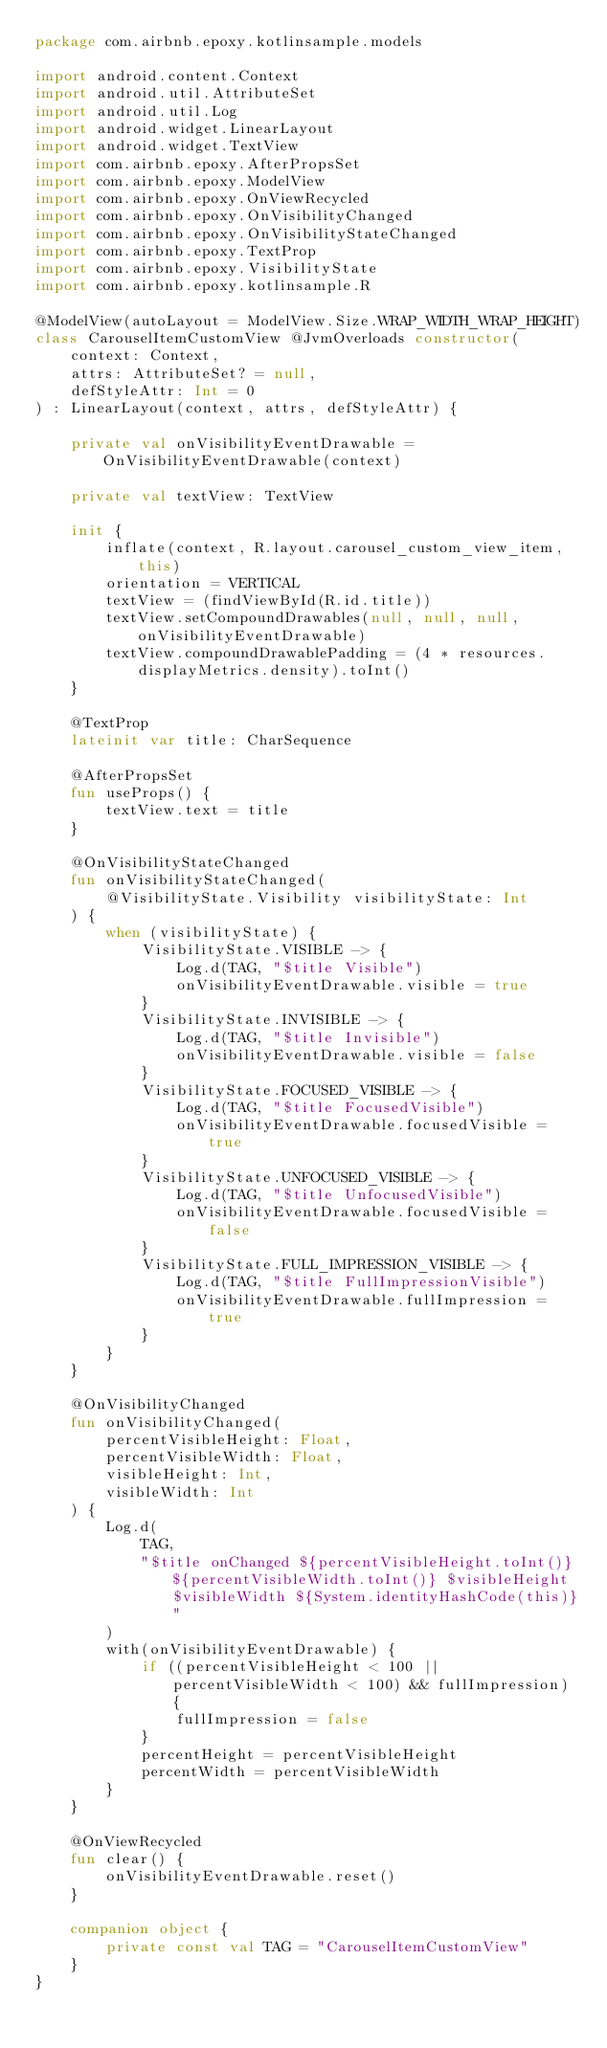<code> <loc_0><loc_0><loc_500><loc_500><_Kotlin_>package com.airbnb.epoxy.kotlinsample.models

import android.content.Context
import android.util.AttributeSet
import android.util.Log
import android.widget.LinearLayout
import android.widget.TextView
import com.airbnb.epoxy.AfterPropsSet
import com.airbnb.epoxy.ModelView
import com.airbnb.epoxy.OnViewRecycled
import com.airbnb.epoxy.OnVisibilityChanged
import com.airbnb.epoxy.OnVisibilityStateChanged
import com.airbnb.epoxy.TextProp
import com.airbnb.epoxy.VisibilityState
import com.airbnb.epoxy.kotlinsample.R

@ModelView(autoLayout = ModelView.Size.WRAP_WIDTH_WRAP_HEIGHT)
class CarouselItemCustomView @JvmOverloads constructor(
    context: Context,
    attrs: AttributeSet? = null,
    defStyleAttr: Int = 0
) : LinearLayout(context, attrs, defStyleAttr) {

    private val onVisibilityEventDrawable = OnVisibilityEventDrawable(context)

    private val textView: TextView

    init {
        inflate(context, R.layout.carousel_custom_view_item, this)
        orientation = VERTICAL
        textView = (findViewById(R.id.title))
        textView.setCompoundDrawables(null, null, null, onVisibilityEventDrawable)
        textView.compoundDrawablePadding = (4 * resources.displayMetrics.density).toInt()
    }

    @TextProp
    lateinit var title: CharSequence

    @AfterPropsSet
    fun useProps() {
        textView.text = title
    }

    @OnVisibilityStateChanged
    fun onVisibilityStateChanged(
        @VisibilityState.Visibility visibilityState: Int
    ) {
        when (visibilityState) {
            VisibilityState.VISIBLE -> {
                Log.d(TAG, "$title Visible")
                onVisibilityEventDrawable.visible = true
            }
            VisibilityState.INVISIBLE -> {
                Log.d(TAG, "$title Invisible")
                onVisibilityEventDrawable.visible = false
            }
            VisibilityState.FOCUSED_VISIBLE -> {
                Log.d(TAG, "$title FocusedVisible")
                onVisibilityEventDrawable.focusedVisible = true
            }
            VisibilityState.UNFOCUSED_VISIBLE -> {
                Log.d(TAG, "$title UnfocusedVisible")
                onVisibilityEventDrawable.focusedVisible = false
            }
            VisibilityState.FULL_IMPRESSION_VISIBLE -> {
                Log.d(TAG, "$title FullImpressionVisible")
                onVisibilityEventDrawable.fullImpression = true
            }
        }
    }

    @OnVisibilityChanged
    fun onVisibilityChanged(
        percentVisibleHeight: Float,
        percentVisibleWidth: Float,
        visibleHeight: Int,
        visibleWidth: Int
    ) {
        Log.d(
            TAG,
            "$title onChanged ${percentVisibleHeight.toInt()} ${percentVisibleWidth.toInt()} $visibleHeight $visibleWidth ${System.identityHashCode(this)}"
        )
        with(onVisibilityEventDrawable) {
            if ((percentVisibleHeight < 100 || percentVisibleWidth < 100) && fullImpression) {
                fullImpression = false
            }
            percentHeight = percentVisibleHeight
            percentWidth = percentVisibleWidth
        }
    }

    @OnViewRecycled
    fun clear() {
        onVisibilityEventDrawable.reset()
    }

    companion object {
        private const val TAG = "CarouselItemCustomView"
    }
}
</code> 